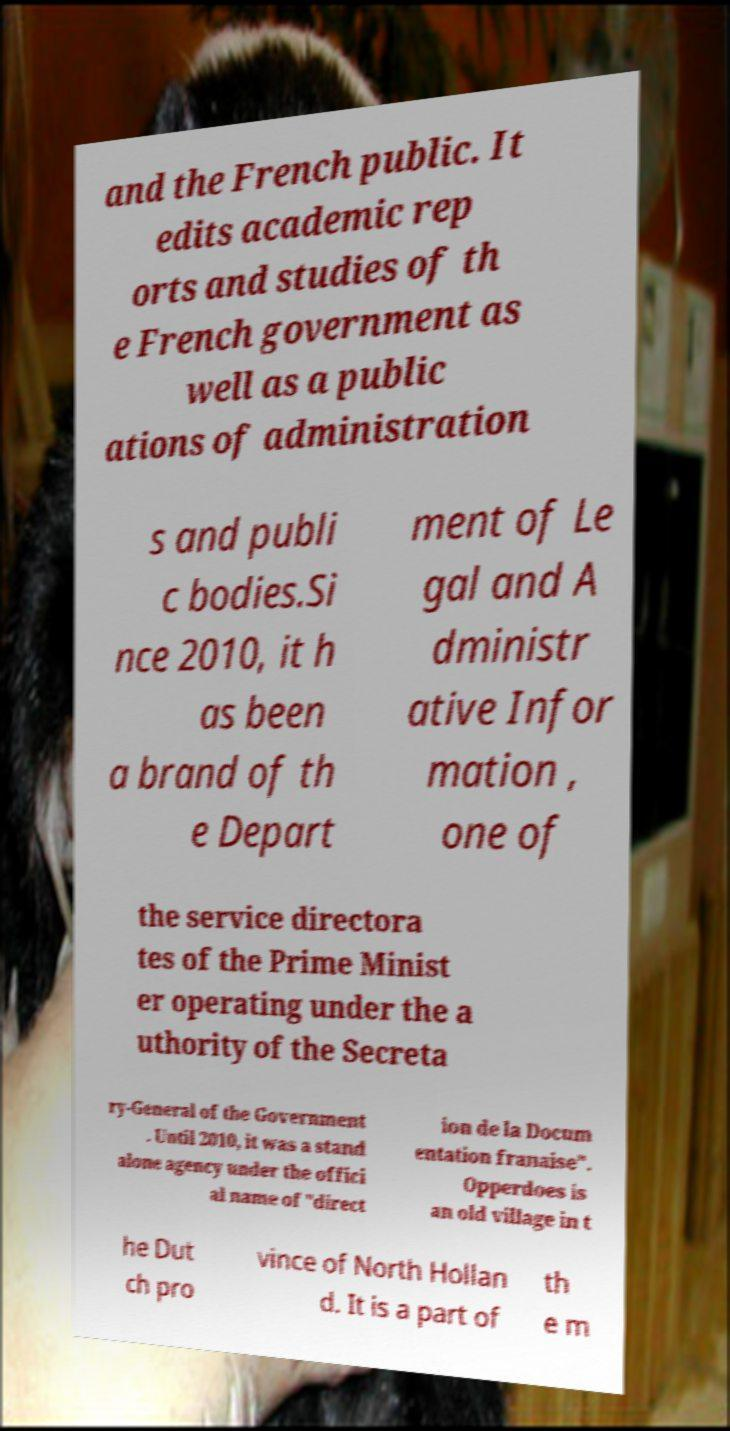Could you assist in decoding the text presented in this image and type it out clearly? and the French public. It edits academic rep orts and studies of th e French government as well as a public ations of administration s and publi c bodies.Si nce 2010, it h as been a brand of th e Depart ment of Le gal and A dministr ative Infor mation , one of the service directora tes of the Prime Minist er operating under the a uthority of the Secreta ry-General of the Government . Until 2010, it was a stand alone agency under the offici al name of "direct ion de la Docum entation franaise". Opperdoes is an old village in t he Dut ch pro vince of North Hollan d. It is a part of th e m 